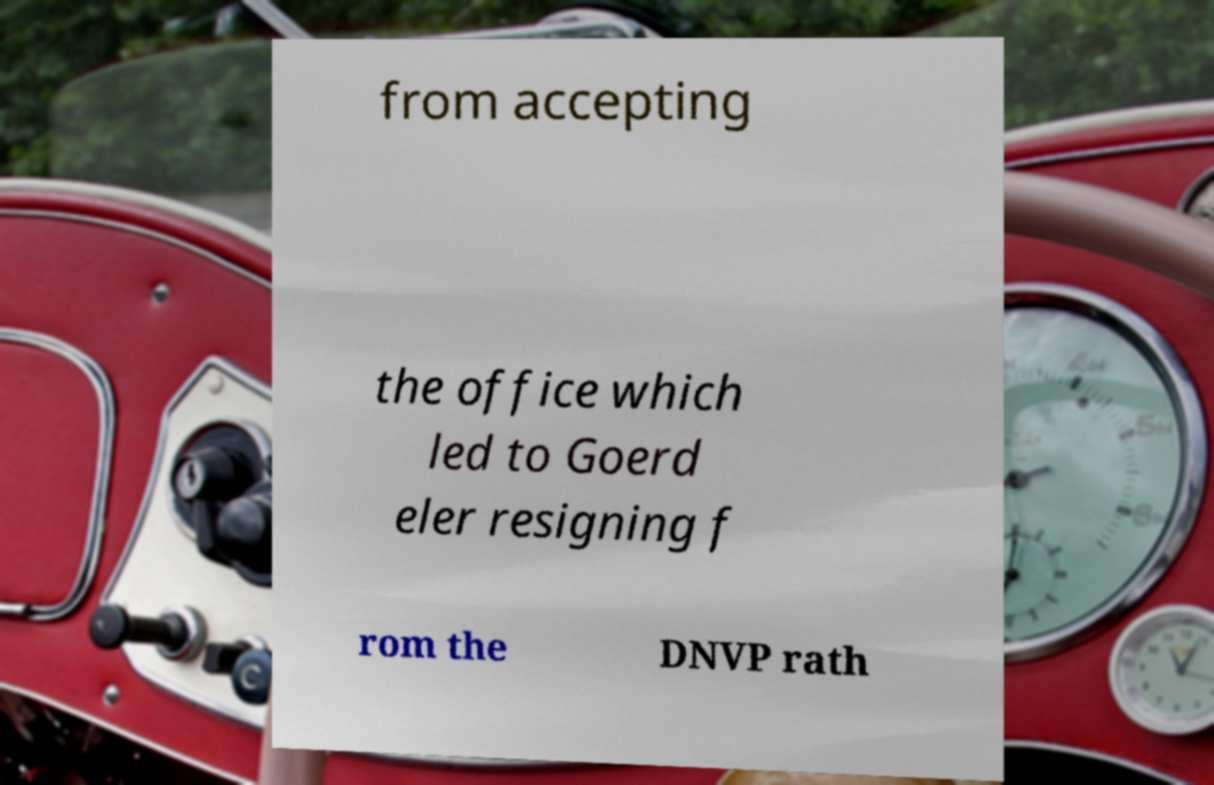Can you accurately transcribe the text from the provided image for me? from accepting the office which led to Goerd eler resigning f rom the DNVP rath 